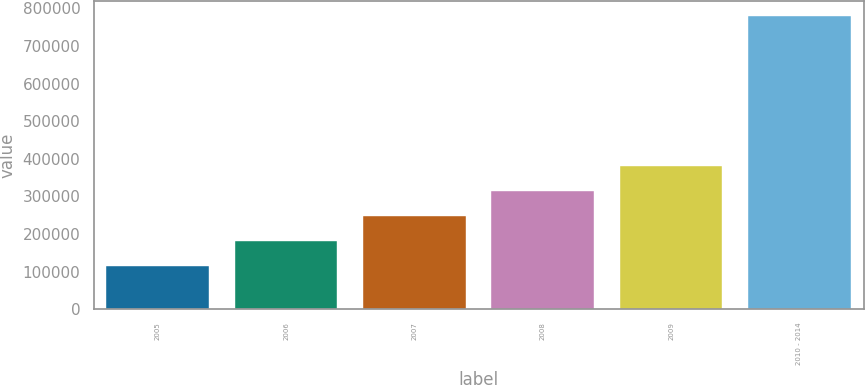Convert chart to OTSL. <chart><loc_0><loc_0><loc_500><loc_500><bar_chart><fcel>2005<fcel>2006<fcel>2007<fcel>2008<fcel>2009<fcel>2010 - 2014<nl><fcel>115203<fcel>181712<fcel>248221<fcel>314731<fcel>381240<fcel>780295<nl></chart> 